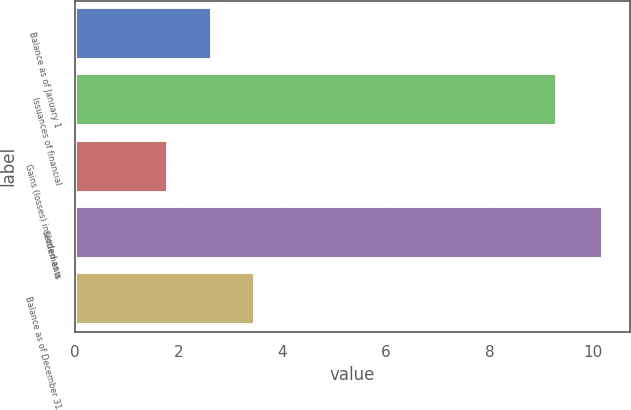Convert chart to OTSL. <chart><loc_0><loc_0><loc_500><loc_500><bar_chart><fcel>Balance as of January 1<fcel>Issuances of financial<fcel>Gains (losses) included as a<fcel>Settlements<fcel>Balance as of December 31<nl><fcel>2.64<fcel>9.3<fcel>1.8<fcel>10.2<fcel>3.48<nl></chart> 